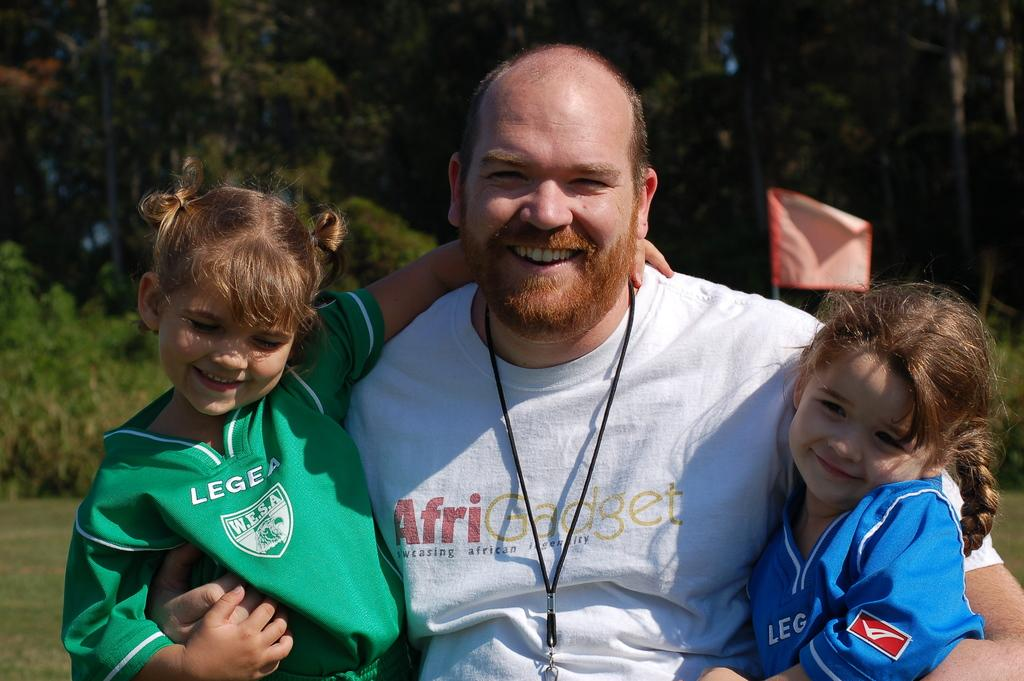<image>
Write a terse but informative summary of the picture. A man in an AfriGadget shirt holds up two young girls. 